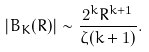<formula> <loc_0><loc_0><loc_500><loc_500>| B _ { K } ( R ) | \sim \frac { 2 ^ { k } R ^ { k + 1 } } { \zeta ( k + 1 ) } .</formula> 